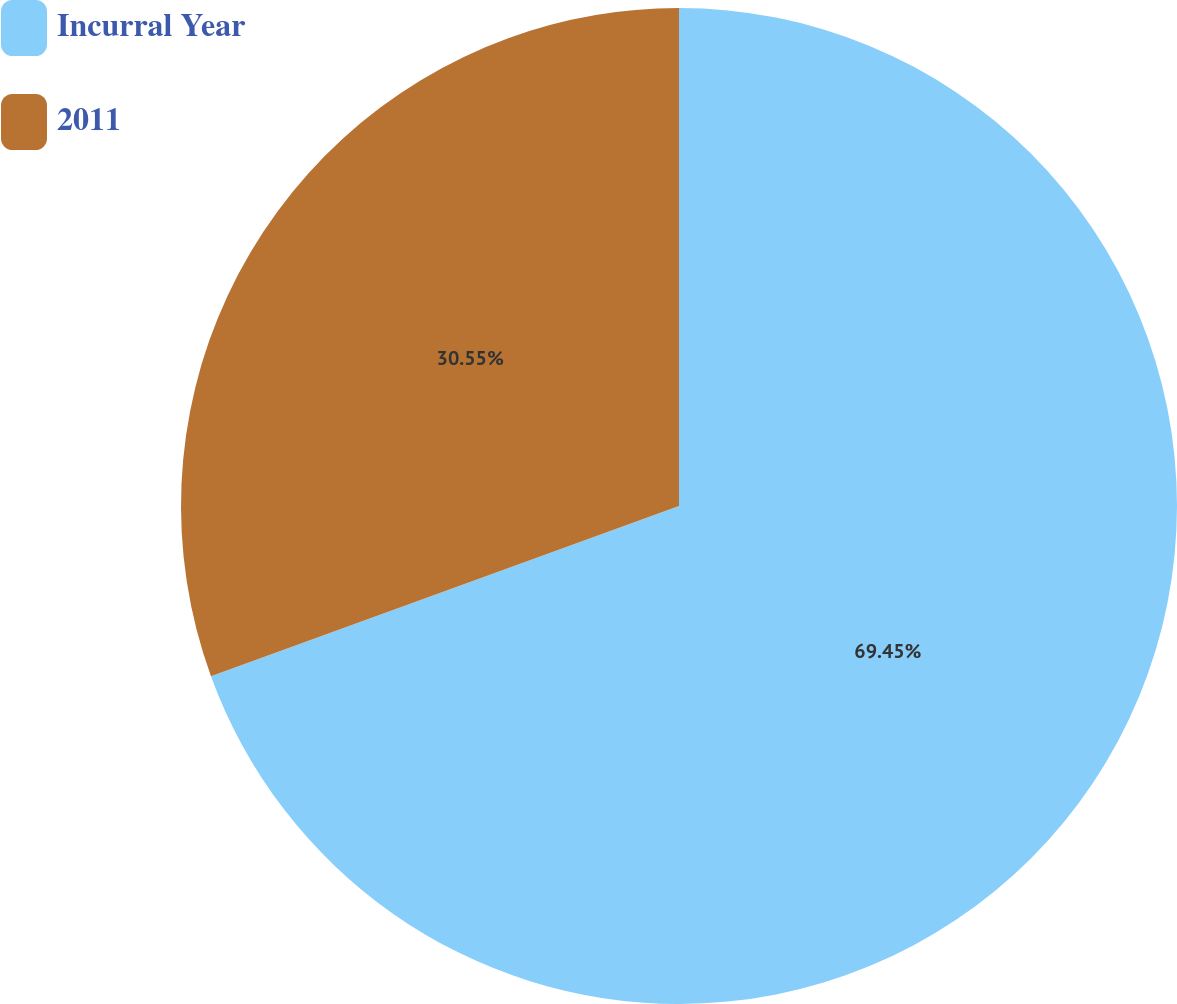Convert chart to OTSL. <chart><loc_0><loc_0><loc_500><loc_500><pie_chart><fcel>Incurral Year<fcel>2011<nl><fcel>69.45%<fcel>30.55%<nl></chart> 